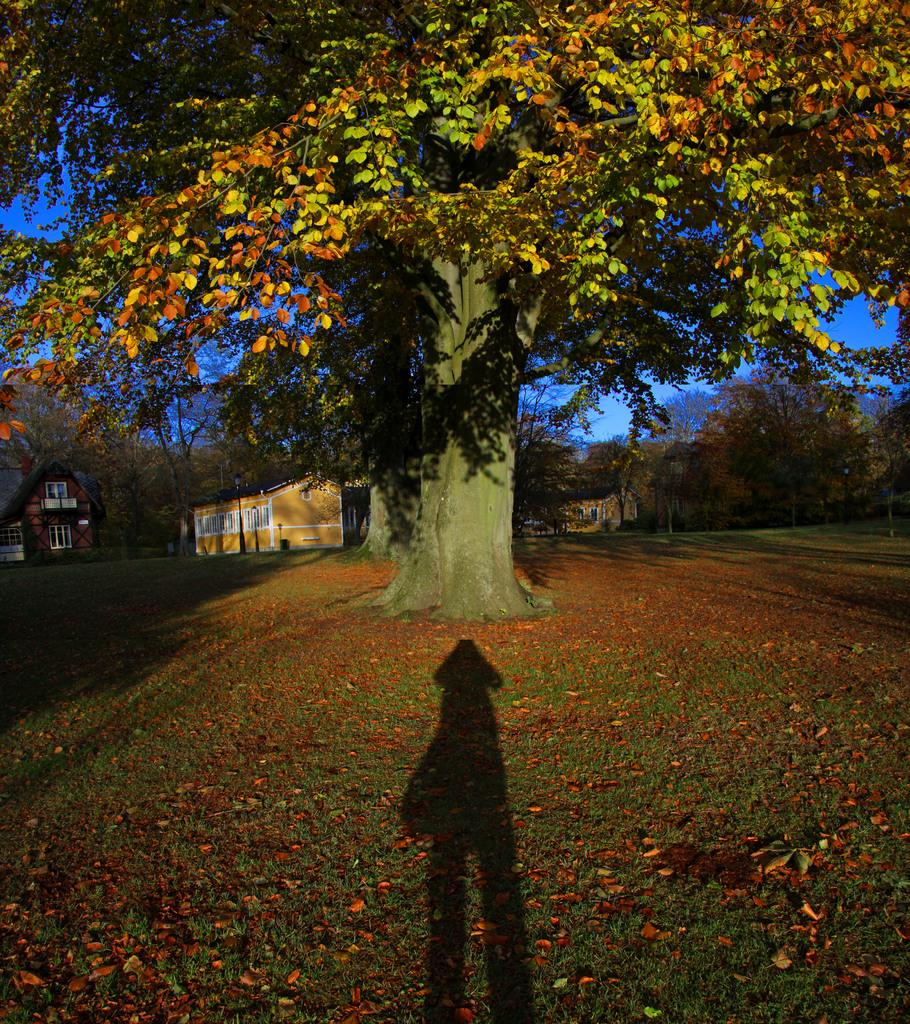What can be seen as a result of an object blocking light in the image? There is a shadow of an object in the image. What type of natural debris can be found on the ground in the image? Dry leaves are present on the ground. What type of vegetation is visible in the image? There are trees in the image. What type of man-made structures are visible in the image? There are houses in the image. What is the color of the sky in the image? The sky is blue in the image. Can you see a table with a hen and geese sitting on it in the image? There is no table, hen, or geese present in the image. 